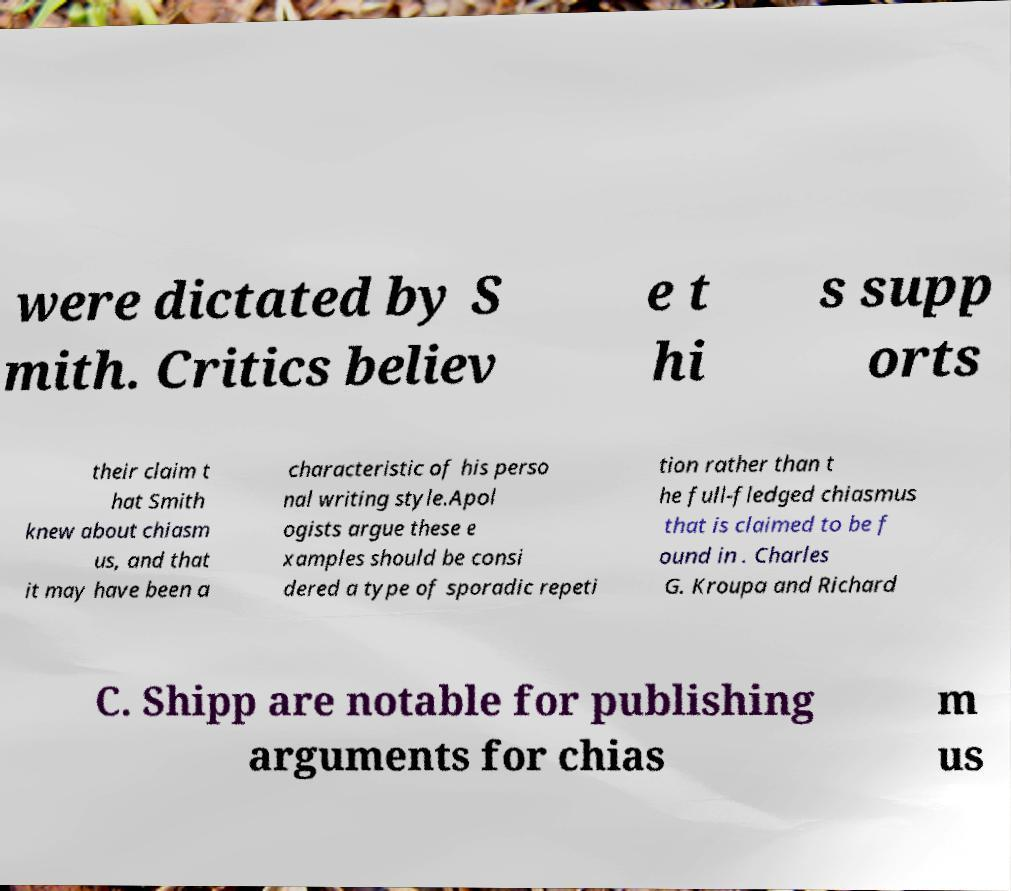What messages or text are displayed in this image? I need them in a readable, typed format. were dictated by S mith. Critics believ e t hi s supp orts their claim t hat Smith knew about chiasm us, and that it may have been a characteristic of his perso nal writing style.Apol ogists argue these e xamples should be consi dered a type of sporadic repeti tion rather than t he full-fledged chiasmus that is claimed to be f ound in . Charles G. Kroupa and Richard C. Shipp are notable for publishing arguments for chias m us 